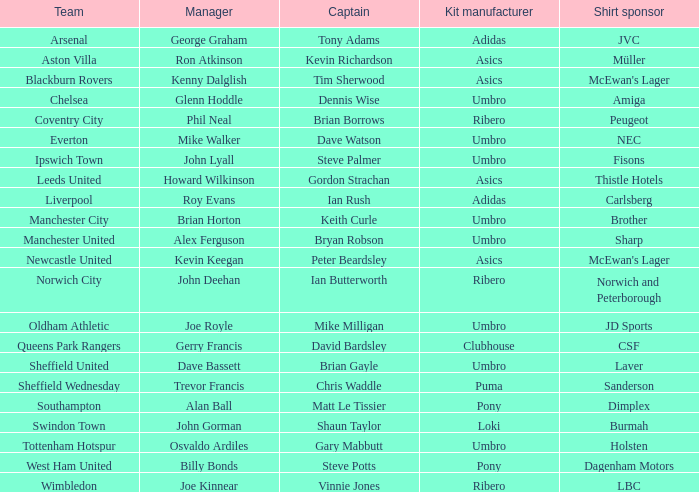I'm looking to parse the entire table for insights. Could you assist me with that? {'header': ['Team', 'Manager', 'Captain', 'Kit manufacturer', 'Shirt sponsor'], 'rows': [['Arsenal', 'George Graham', 'Tony Adams', 'Adidas', 'JVC'], ['Aston Villa', 'Ron Atkinson', 'Kevin Richardson', 'Asics', 'Müller'], ['Blackburn Rovers', 'Kenny Dalglish', 'Tim Sherwood', 'Asics', "McEwan's Lager"], ['Chelsea', 'Glenn Hoddle', 'Dennis Wise', 'Umbro', 'Amiga'], ['Coventry City', 'Phil Neal', 'Brian Borrows', 'Ribero', 'Peugeot'], ['Everton', 'Mike Walker', 'Dave Watson', 'Umbro', 'NEC'], ['Ipswich Town', 'John Lyall', 'Steve Palmer', 'Umbro', 'Fisons'], ['Leeds United', 'Howard Wilkinson', 'Gordon Strachan', 'Asics', 'Thistle Hotels'], ['Liverpool', 'Roy Evans', 'Ian Rush', 'Adidas', 'Carlsberg'], ['Manchester City', 'Brian Horton', 'Keith Curle', 'Umbro', 'Brother'], ['Manchester United', 'Alex Ferguson', 'Bryan Robson', 'Umbro', 'Sharp'], ['Newcastle United', 'Kevin Keegan', 'Peter Beardsley', 'Asics', "McEwan's Lager"], ['Norwich City', 'John Deehan', 'Ian Butterworth', 'Ribero', 'Norwich and Peterborough'], ['Oldham Athletic', 'Joe Royle', 'Mike Milligan', 'Umbro', 'JD Sports'], ['Queens Park Rangers', 'Gerry Francis', 'David Bardsley', 'Clubhouse', 'CSF'], ['Sheffield United', 'Dave Bassett', 'Brian Gayle', 'Umbro', 'Laver'], ['Sheffield Wednesday', 'Trevor Francis', 'Chris Waddle', 'Puma', 'Sanderson'], ['Southampton', 'Alan Ball', 'Matt Le Tissier', 'Pony', 'Dimplex'], ['Swindon Town', 'John Gorman', 'Shaun Taylor', 'Loki', 'Burmah'], ['Tottenham Hotspur', 'Osvaldo Ardiles', 'Gary Mabbutt', 'Umbro', 'Holsten'], ['West Ham United', 'Billy Bonds', 'Steve Potts', 'Pony', 'Dagenham Motors'], ['Wimbledon', 'Joe Kinnear', 'Vinnie Jones', 'Ribero', 'LBC']]} Which captain has billy bonds as the manager? Steve Potts. 